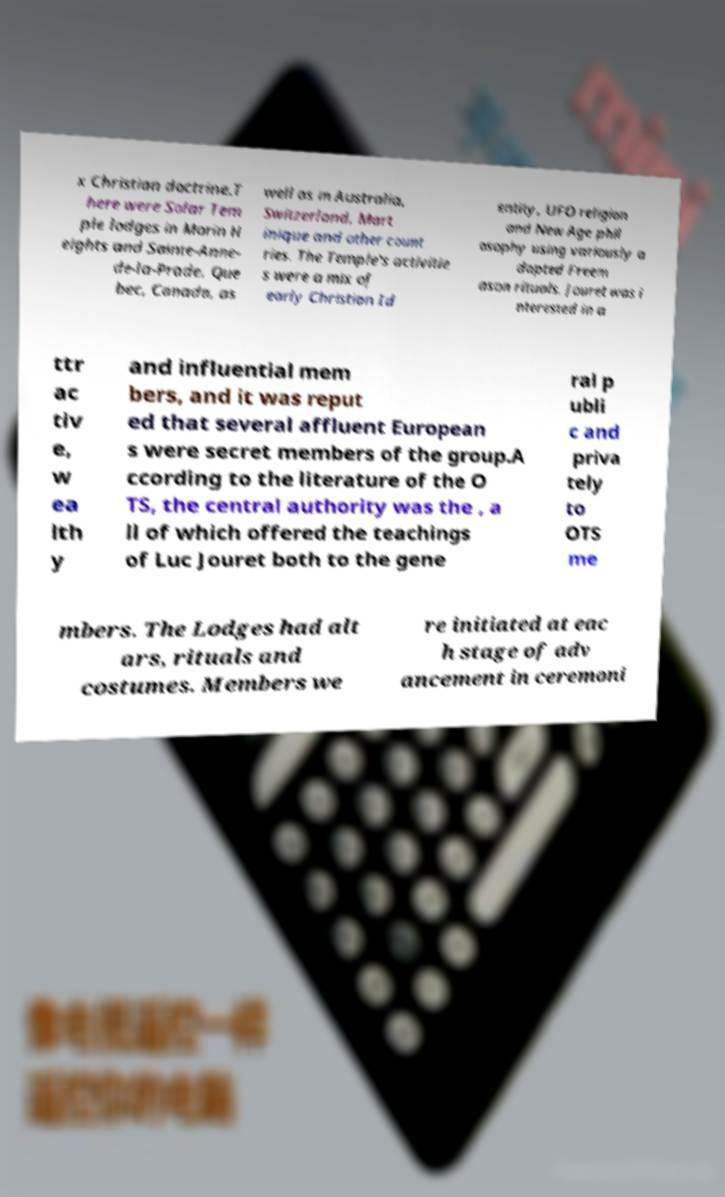What messages or text are displayed in this image? I need them in a readable, typed format. x Christian doctrine.T here were Solar Tem ple lodges in Morin H eights and Sainte-Anne- de-la-Prade, Que bec, Canada, as well as in Australia, Switzerland, Mart inique and other count ries. The Temple's activitie s were a mix of early Christian Id entity, UFO religion and New Age phil osophy using variously a dapted Freem ason rituals. Jouret was i nterested in a ttr ac tiv e, w ea lth y and influential mem bers, and it was reput ed that several affluent European s were secret members of the group.A ccording to the literature of the O TS, the central authority was the , a ll of which offered the teachings of Luc Jouret both to the gene ral p ubli c and priva tely to OTS me mbers. The Lodges had alt ars, rituals and costumes. Members we re initiated at eac h stage of adv ancement in ceremoni 